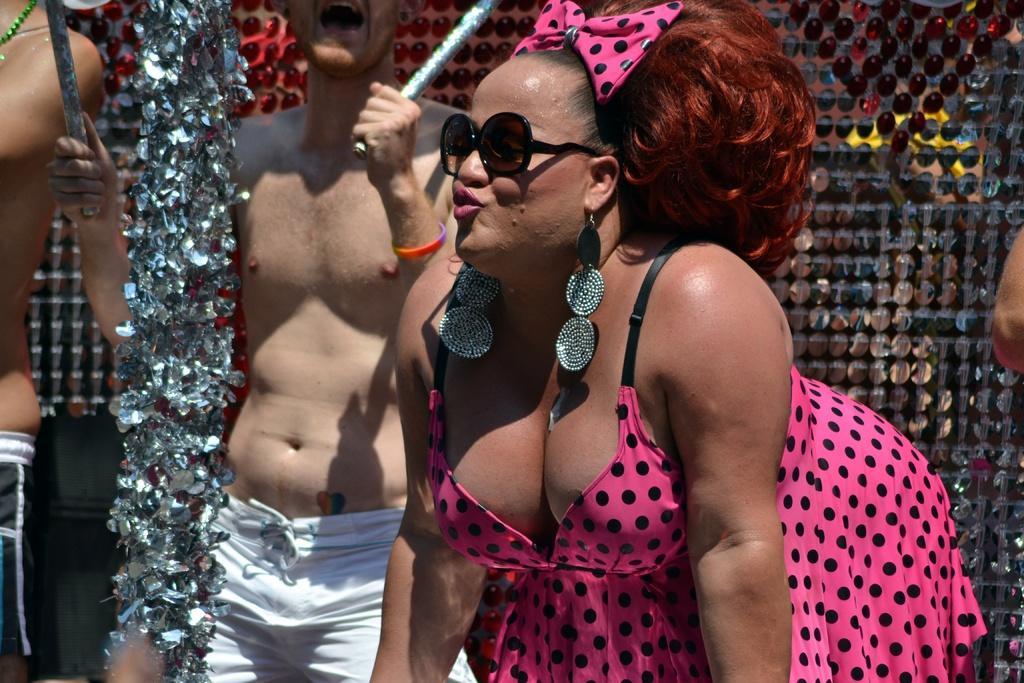Please provide a concise description of this image. This picture consists of three persons and in the middle person he holding sticks, in the background there is a decorative fence visible , on the right side I can see person hand 